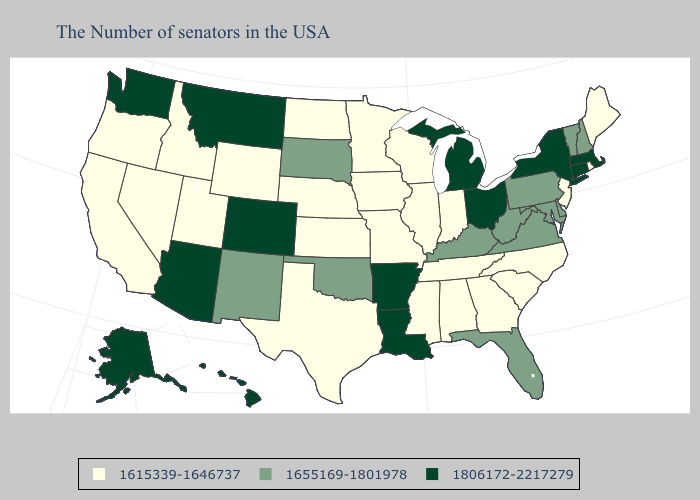What is the lowest value in the USA?
Answer briefly. 1615339-1646737. Among the states that border Minnesota , which have the highest value?
Write a very short answer. South Dakota. Name the states that have a value in the range 1806172-2217279?
Be succinct. Massachusetts, Connecticut, New York, Ohio, Michigan, Louisiana, Arkansas, Colorado, Montana, Arizona, Washington, Alaska, Hawaii. What is the lowest value in the USA?
Give a very brief answer. 1615339-1646737. Name the states that have a value in the range 1655169-1801978?
Quick response, please. New Hampshire, Vermont, Delaware, Maryland, Pennsylvania, Virginia, West Virginia, Florida, Kentucky, Oklahoma, South Dakota, New Mexico. What is the lowest value in states that border Idaho?
Write a very short answer. 1615339-1646737. Which states have the highest value in the USA?
Short answer required. Massachusetts, Connecticut, New York, Ohio, Michigan, Louisiana, Arkansas, Colorado, Montana, Arizona, Washington, Alaska, Hawaii. Among the states that border Michigan , does Ohio have the highest value?
Quick response, please. Yes. What is the lowest value in the USA?
Be succinct. 1615339-1646737. What is the lowest value in the USA?
Keep it brief. 1615339-1646737. What is the value of Arkansas?
Concise answer only. 1806172-2217279. Does New Hampshire have a lower value than New Mexico?
Keep it brief. No. What is the value of Kansas?
Quick response, please. 1615339-1646737. Does the map have missing data?
Concise answer only. No. Among the states that border New Mexico , does Arizona have the lowest value?
Keep it brief. No. 